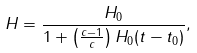Convert formula to latex. <formula><loc_0><loc_0><loc_500><loc_500>H = \frac { H _ { 0 } } { 1 + \left ( \frac { c - 1 } { c } \right ) H _ { 0 } ( t - t _ { 0 } ) } ,</formula> 